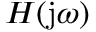<formula> <loc_0><loc_0><loc_500><loc_500>H ( j \omega )</formula> 